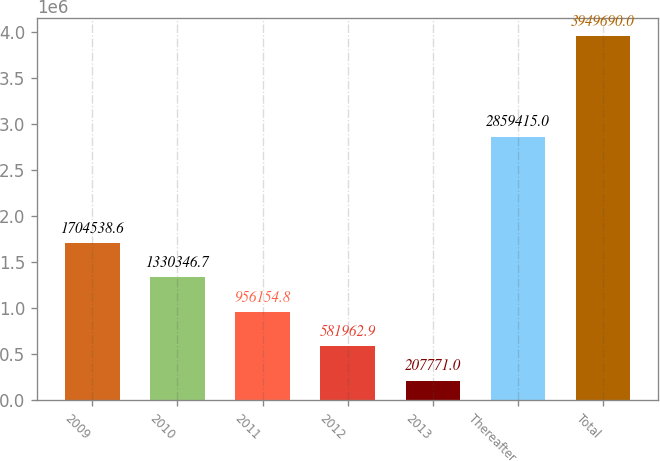<chart> <loc_0><loc_0><loc_500><loc_500><bar_chart><fcel>2009<fcel>2010<fcel>2011<fcel>2012<fcel>2013<fcel>Thereafter<fcel>Total<nl><fcel>1.70454e+06<fcel>1.33035e+06<fcel>956155<fcel>581963<fcel>207771<fcel>2.85942e+06<fcel>3.94969e+06<nl></chart> 